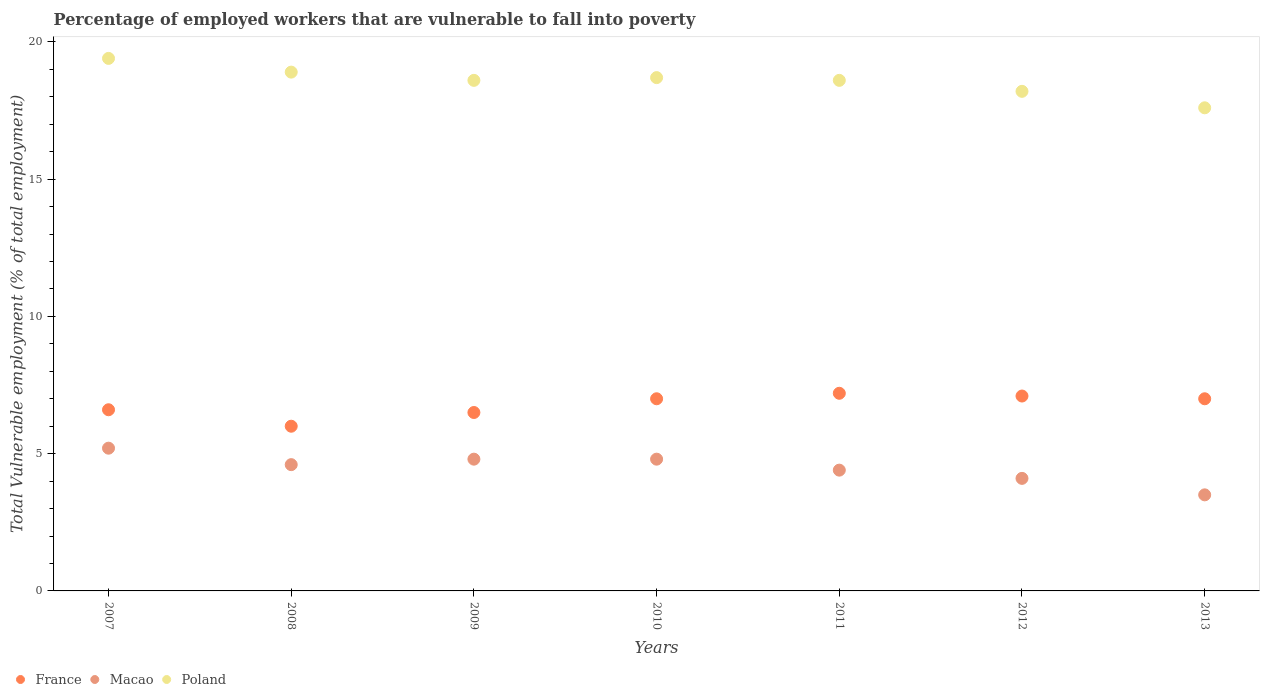Is the number of dotlines equal to the number of legend labels?
Make the answer very short. Yes. What is the percentage of employed workers who are vulnerable to fall into poverty in Macao in 2013?
Your answer should be very brief. 3.5. Across all years, what is the maximum percentage of employed workers who are vulnerable to fall into poverty in Poland?
Offer a very short reply. 19.4. In which year was the percentage of employed workers who are vulnerable to fall into poverty in Poland maximum?
Keep it short and to the point. 2007. In which year was the percentage of employed workers who are vulnerable to fall into poverty in Macao minimum?
Keep it short and to the point. 2013. What is the total percentage of employed workers who are vulnerable to fall into poverty in France in the graph?
Make the answer very short. 47.4. What is the difference between the percentage of employed workers who are vulnerable to fall into poverty in France in 2007 and that in 2012?
Keep it short and to the point. -0.5. What is the difference between the percentage of employed workers who are vulnerable to fall into poverty in France in 2012 and the percentage of employed workers who are vulnerable to fall into poverty in Macao in 2009?
Your answer should be compact. 2.3. What is the average percentage of employed workers who are vulnerable to fall into poverty in Macao per year?
Provide a succinct answer. 4.49. In the year 2007, what is the difference between the percentage of employed workers who are vulnerable to fall into poverty in Macao and percentage of employed workers who are vulnerable to fall into poverty in Poland?
Offer a very short reply. -14.2. In how many years, is the percentage of employed workers who are vulnerable to fall into poverty in Poland greater than 19 %?
Ensure brevity in your answer.  1. What is the ratio of the percentage of employed workers who are vulnerable to fall into poverty in Macao in 2007 to that in 2008?
Provide a succinct answer. 1.13. Is the percentage of employed workers who are vulnerable to fall into poverty in Macao in 2007 less than that in 2009?
Your response must be concise. No. What is the difference between the highest and the second highest percentage of employed workers who are vulnerable to fall into poverty in France?
Your answer should be compact. 0.1. What is the difference between the highest and the lowest percentage of employed workers who are vulnerable to fall into poverty in France?
Your answer should be very brief. 1.2. In how many years, is the percentage of employed workers who are vulnerable to fall into poverty in Macao greater than the average percentage of employed workers who are vulnerable to fall into poverty in Macao taken over all years?
Provide a succinct answer. 4. Is it the case that in every year, the sum of the percentage of employed workers who are vulnerable to fall into poverty in France and percentage of employed workers who are vulnerable to fall into poverty in Macao  is greater than the percentage of employed workers who are vulnerable to fall into poverty in Poland?
Offer a very short reply. No. Is the percentage of employed workers who are vulnerable to fall into poverty in France strictly greater than the percentage of employed workers who are vulnerable to fall into poverty in Poland over the years?
Ensure brevity in your answer.  No. How many years are there in the graph?
Ensure brevity in your answer.  7. Are the values on the major ticks of Y-axis written in scientific E-notation?
Make the answer very short. No. Does the graph contain any zero values?
Your answer should be compact. No. How many legend labels are there?
Your response must be concise. 3. How are the legend labels stacked?
Your response must be concise. Horizontal. What is the title of the graph?
Offer a very short reply. Percentage of employed workers that are vulnerable to fall into poverty. What is the label or title of the Y-axis?
Your answer should be compact. Total Vulnerable employment (% of total employment). What is the Total Vulnerable employment (% of total employment) of France in 2007?
Your answer should be very brief. 6.6. What is the Total Vulnerable employment (% of total employment) of Macao in 2007?
Offer a very short reply. 5.2. What is the Total Vulnerable employment (% of total employment) of Poland in 2007?
Keep it short and to the point. 19.4. What is the Total Vulnerable employment (% of total employment) of Macao in 2008?
Your answer should be very brief. 4.6. What is the Total Vulnerable employment (% of total employment) in Poland in 2008?
Make the answer very short. 18.9. What is the Total Vulnerable employment (% of total employment) of Macao in 2009?
Make the answer very short. 4.8. What is the Total Vulnerable employment (% of total employment) in Poland in 2009?
Ensure brevity in your answer.  18.6. What is the Total Vulnerable employment (% of total employment) of France in 2010?
Ensure brevity in your answer.  7. What is the Total Vulnerable employment (% of total employment) of Macao in 2010?
Your answer should be compact. 4.8. What is the Total Vulnerable employment (% of total employment) of Poland in 2010?
Ensure brevity in your answer.  18.7. What is the Total Vulnerable employment (% of total employment) in France in 2011?
Give a very brief answer. 7.2. What is the Total Vulnerable employment (% of total employment) in Macao in 2011?
Offer a terse response. 4.4. What is the Total Vulnerable employment (% of total employment) in Poland in 2011?
Your answer should be very brief. 18.6. What is the Total Vulnerable employment (% of total employment) in France in 2012?
Your answer should be very brief. 7.1. What is the Total Vulnerable employment (% of total employment) of Macao in 2012?
Give a very brief answer. 4.1. What is the Total Vulnerable employment (% of total employment) of Poland in 2012?
Offer a very short reply. 18.2. What is the Total Vulnerable employment (% of total employment) of Poland in 2013?
Ensure brevity in your answer.  17.6. Across all years, what is the maximum Total Vulnerable employment (% of total employment) in France?
Your response must be concise. 7.2. Across all years, what is the maximum Total Vulnerable employment (% of total employment) in Macao?
Provide a short and direct response. 5.2. Across all years, what is the maximum Total Vulnerable employment (% of total employment) in Poland?
Give a very brief answer. 19.4. Across all years, what is the minimum Total Vulnerable employment (% of total employment) of France?
Provide a short and direct response. 6. Across all years, what is the minimum Total Vulnerable employment (% of total employment) of Macao?
Your answer should be very brief. 3.5. Across all years, what is the minimum Total Vulnerable employment (% of total employment) in Poland?
Your answer should be compact. 17.6. What is the total Total Vulnerable employment (% of total employment) of France in the graph?
Your response must be concise. 47.4. What is the total Total Vulnerable employment (% of total employment) of Macao in the graph?
Offer a very short reply. 31.4. What is the total Total Vulnerable employment (% of total employment) of Poland in the graph?
Provide a short and direct response. 130. What is the difference between the Total Vulnerable employment (% of total employment) in France in 2007 and that in 2009?
Ensure brevity in your answer.  0.1. What is the difference between the Total Vulnerable employment (% of total employment) of Poland in 2007 and that in 2009?
Offer a terse response. 0.8. What is the difference between the Total Vulnerable employment (% of total employment) of France in 2007 and that in 2010?
Your response must be concise. -0.4. What is the difference between the Total Vulnerable employment (% of total employment) of Macao in 2007 and that in 2010?
Provide a short and direct response. 0.4. What is the difference between the Total Vulnerable employment (% of total employment) in Poland in 2007 and that in 2010?
Provide a short and direct response. 0.7. What is the difference between the Total Vulnerable employment (% of total employment) in France in 2007 and that in 2011?
Offer a very short reply. -0.6. What is the difference between the Total Vulnerable employment (% of total employment) of France in 2007 and that in 2012?
Your response must be concise. -0.5. What is the difference between the Total Vulnerable employment (% of total employment) of Macao in 2007 and that in 2012?
Make the answer very short. 1.1. What is the difference between the Total Vulnerable employment (% of total employment) in France in 2007 and that in 2013?
Offer a very short reply. -0.4. What is the difference between the Total Vulnerable employment (% of total employment) in Macao in 2007 and that in 2013?
Your response must be concise. 1.7. What is the difference between the Total Vulnerable employment (% of total employment) of Poland in 2007 and that in 2013?
Your response must be concise. 1.8. What is the difference between the Total Vulnerable employment (% of total employment) of Poland in 2008 and that in 2009?
Your answer should be very brief. 0.3. What is the difference between the Total Vulnerable employment (% of total employment) of France in 2008 and that in 2010?
Offer a very short reply. -1. What is the difference between the Total Vulnerable employment (% of total employment) of Macao in 2008 and that in 2010?
Provide a short and direct response. -0.2. What is the difference between the Total Vulnerable employment (% of total employment) in Poland in 2008 and that in 2010?
Keep it short and to the point. 0.2. What is the difference between the Total Vulnerable employment (% of total employment) in Macao in 2008 and that in 2011?
Give a very brief answer. 0.2. What is the difference between the Total Vulnerable employment (% of total employment) in Macao in 2008 and that in 2012?
Provide a succinct answer. 0.5. What is the difference between the Total Vulnerable employment (% of total employment) of France in 2008 and that in 2013?
Your answer should be compact. -1. What is the difference between the Total Vulnerable employment (% of total employment) in Macao in 2008 and that in 2013?
Offer a very short reply. 1.1. What is the difference between the Total Vulnerable employment (% of total employment) of Poland in 2008 and that in 2013?
Your answer should be compact. 1.3. What is the difference between the Total Vulnerable employment (% of total employment) of Poland in 2009 and that in 2010?
Offer a terse response. -0.1. What is the difference between the Total Vulnerable employment (% of total employment) in France in 2009 and that in 2011?
Offer a very short reply. -0.7. What is the difference between the Total Vulnerable employment (% of total employment) of France in 2009 and that in 2012?
Your response must be concise. -0.6. What is the difference between the Total Vulnerable employment (% of total employment) of France in 2009 and that in 2013?
Offer a terse response. -0.5. What is the difference between the Total Vulnerable employment (% of total employment) of Macao in 2009 and that in 2013?
Keep it short and to the point. 1.3. What is the difference between the Total Vulnerable employment (% of total employment) of Poland in 2009 and that in 2013?
Offer a terse response. 1. What is the difference between the Total Vulnerable employment (% of total employment) of France in 2010 and that in 2011?
Your answer should be very brief. -0.2. What is the difference between the Total Vulnerable employment (% of total employment) in Poland in 2010 and that in 2011?
Offer a terse response. 0.1. What is the difference between the Total Vulnerable employment (% of total employment) in France in 2010 and that in 2012?
Provide a succinct answer. -0.1. What is the difference between the Total Vulnerable employment (% of total employment) in France in 2010 and that in 2013?
Keep it short and to the point. 0. What is the difference between the Total Vulnerable employment (% of total employment) of Macao in 2010 and that in 2013?
Your answer should be very brief. 1.3. What is the difference between the Total Vulnerable employment (% of total employment) of Poland in 2010 and that in 2013?
Ensure brevity in your answer.  1.1. What is the difference between the Total Vulnerable employment (% of total employment) of France in 2011 and that in 2012?
Make the answer very short. 0.1. What is the difference between the Total Vulnerable employment (% of total employment) in Macao in 2011 and that in 2012?
Make the answer very short. 0.3. What is the difference between the Total Vulnerable employment (% of total employment) in Poland in 2011 and that in 2012?
Your answer should be compact. 0.4. What is the difference between the Total Vulnerable employment (% of total employment) of France in 2011 and that in 2013?
Your answer should be very brief. 0.2. What is the difference between the Total Vulnerable employment (% of total employment) in Macao in 2011 and that in 2013?
Give a very brief answer. 0.9. What is the difference between the Total Vulnerable employment (% of total employment) of Poland in 2011 and that in 2013?
Ensure brevity in your answer.  1. What is the difference between the Total Vulnerable employment (% of total employment) in Macao in 2012 and that in 2013?
Give a very brief answer. 0.6. What is the difference between the Total Vulnerable employment (% of total employment) of Poland in 2012 and that in 2013?
Keep it short and to the point. 0.6. What is the difference between the Total Vulnerable employment (% of total employment) of Macao in 2007 and the Total Vulnerable employment (% of total employment) of Poland in 2008?
Ensure brevity in your answer.  -13.7. What is the difference between the Total Vulnerable employment (% of total employment) of France in 2007 and the Total Vulnerable employment (% of total employment) of Macao in 2009?
Offer a very short reply. 1.8. What is the difference between the Total Vulnerable employment (% of total employment) in France in 2007 and the Total Vulnerable employment (% of total employment) in Macao in 2010?
Offer a very short reply. 1.8. What is the difference between the Total Vulnerable employment (% of total employment) of Macao in 2007 and the Total Vulnerable employment (% of total employment) of Poland in 2010?
Give a very brief answer. -13.5. What is the difference between the Total Vulnerable employment (% of total employment) of France in 2007 and the Total Vulnerable employment (% of total employment) of Macao in 2011?
Your response must be concise. 2.2. What is the difference between the Total Vulnerable employment (% of total employment) in Macao in 2007 and the Total Vulnerable employment (% of total employment) in Poland in 2011?
Provide a short and direct response. -13.4. What is the difference between the Total Vulnerable employment (% of total employment) of France in 2007 and the Total Vulnerable employment (% of total employment) of Macao in 2012?
Offer a very short reply. 2.5. What is the difference between the Total Vulnerable employment (% of total employment) of France in 2007 and the Total Vulnerable employment (% of total employment) of Macao in 2013?
Your answer should be very brief. 3.1. What is the difference between the Total Vulnerable employment (% of total employment) of France in 2007 and the Total Vulnerable employment (% of total employment) of Poland in 2013?
Keep it short and to the point. -11. What is the difference between the Total Vulnerable employment (% of total employment) in Macao in 2007 and the Total Vulnerable employment (% of total employment) in Poland in 2013?
Offer a terse response. -12.4. What is the difference between the Total Vulnerable employment (% of total employment) in France in 2008 and the Total Vulnerable employment (% of total employment) in Macao in 2009?
Keep it short and to the point. 1.2. What is the difference between the Total Vulnerable employment (% of total employment) of Macao in 2008 and the Total Vulnerable employment (% of total employment) of Poland in 2009?
Your response must be concise. -14. What is the difference between the Total Vulnerable employment (% of total employment) of France in 2008 and the Total Vulnerable employment (% of total employment) of Poland in 2010?
Make the answer very short. -12.7. What is the difference between the Total Vulnerable employment (% of total employment) in Macao in 2008 and the Total Vulnerable employment (% of total employment) in Poland in 2010?
Your response must be concise. -14.1. What is the difference between the Total Vulnerable employment (% of total employment) of France in 2008 and the Total Vulnerable employment (% of total employment) of Macao in 2012?
Make the answer very short. 1.9. What is the difference between the Total Vulnerable employment (% of total employment) of Macao in 2008 and the Total Vulnerable employment (% of total employment) of Poland in 2012?
Ensure brevity in your answer.  -13.6. What is the difference between the Total Vulnerable employment (% of total employment) in Macao in 2009 and the Total Vulnerable employment (% of total employment) in Poland in 2010?
Provide a short and direct response. -13.9. What is the difference between the Total Vulnerable employment (% of total employment) in France in 2009 and the Total Vulnerable employment (% of total employment) in Macao in 2011?
Your answer should be very brief. 2.1. What is the difference between the Total Vulnerable employment (% of total employment) in France in 2009 and the Total Vulnerable employment (% of total employment) in Poland in 2012?
Your response must be concise. -11.7. What is the difference between the Total Vulnerable employment (% of total employment) of Macao in 2009 and the Total Vulnerable employment (% of total employment) of Poland in 2012?
Your response must be concise. -13.4. What is the difference between the Total Vulnerable employment (% of total employment) in France in 2009 and the Total Vulnerable employment (% of total employment) in Poland in 2013?
Keep it short and to the point. -11.1. What is the difference between the Total Vulnerable employment (% of total employment) in Macao in 2009 and the Total Vulnerable employment (% of total employment) in Poland in 2013?
Your answer should be compact. -12.8. What is the difference between the Total Vulnerable employment (% of total employment) in France in 2010 and the Total Vulnerable employment (% of total employment) in Poland in 2011?
Keep it short and to the point. -11.6. What is the difference between the Total Vulnerable employment (% of total employment) of France in 2010 and the Total Vulnerable employment (% of total employment) of Poland in 2012?
Keep it short and to the point. -11.2. What is the difference between the Total Vulnerable employment (% of total employment) in Macao in 2010 and the Total Vulnerable employment (% of total employment) in Poland in 2012?
Offer a very short reply. -13.4. What is the difference between the Total Vulnerable employment (% of total employment) in Macao in 2010 and the Total Vulnerable employment (% of total employment) in Poland in 2013?
Give a very brief answer. -12.8. What is the difference between the Total Vulnerable employment (% of total employment) of France in 2011 and the Total Vulnerable employment (% of total employment) of Macao in 2012?
Ensure brevity in your answer.  3.1. What is the difference between the Total Vulnerable employment (% of total employment) in France in 2011 and the Total Vulnerable employment (% of total employment) in Poland in 2012?
Provide a succinct answer. -11. What is the difference between the Total Vulnerable employment (% of total employment) in Macao in 2011 and the Total Vulnerable employment (% of total employment) in Poland in 2012?
Your answer should be compact. -13.8. What is the difference between the Total Vulnerable employment (% of total employment) of France in 2011 and the Total Vulnerable employment (% of total employment) of Macao in 2013?
Keep it short and to the point. 3.7. What is the difference between the Total Vulnerable employment (% of total employment) in France in 2011 and the Total Vulnerable employment (% of total employment) in Poland in 2013?
Your answer should be very brief. -10.4. What is the difference between the Total Vulnerable employment (% of total employment) of Macao in 2011 and the Total Vulnerable employment (% of total employment) of Poland in 2013?
Provide a short and direct response. -13.2. What is the difference between the Total Vulnerable employment (% of total employment) in France in 2012 and the Total Vulnerable employment (% of total employment) in Poland in 2013?
Ensure brevity in your answer.  -10.5. What is the difference between the Total Vulnerable employment (% of total employment) of Macao in 2012 and the Total Vulnerable employment (% of total employment) of Poland in 2013?
Provide a short and direct response. -13.5. What is the average Total Vulnerable employment (% of total employment) of France per year?
Provide a short and direct response. 6.77. What is the average Total Vulnerable employment (% of total employment) in Macao per year?
Make the answer very short. 4.49. What is the average Total Vulnerable employment (% of total employment) of Poland per year?
Keep it short and to the point. 18.57. In the year 2007, what is the difference between the Total Vulnerable employment (% of total employment) in France and Total Vulnerable employment (% of total employment) in Macao?
Offer a terse response. 1.4. In the year 2007, what is the difference between the Total Vulnerable employment (% of total employment) of France and Total Vulnerable employment (% of total employment) of Poland?
Your response must be concise. -12.8. In the year 2008, what is the difference between the Total Vulnerable employment (% of total employment) in France and Total Vulnerable employment (% of total employment) in Macao?
Keep it short and to the point. 1.4. In the year 2008, what is the difference between the Total Vulnerable employment (% of total employment) in Macao and Total Vulnerable employment (% of total employment) in Poland?
Keep it short and to the point. -14.3. In the year 2009, what is the difference between the Total Vulnerable employment (% of total employment) of France and Total Vulnerable employment (% of total employment) of Poland?
Provide a short and direct response. -12.1. In the year 2009, what is the difference between the Total Vulnerable employment (% of total employment) of Macao and Total Vulnerable employment (% of total employment) of Poland?
Provide a succinct answer. -13.8. In the year 2010, what is the difference between the Total Vulnerable employment (% of total employment) in France and Total Vulnerable employment (% of total employment) in Poland?
Offer a very short reply. -11.7. In the year 2010, what is the difference between the Total Vulnerable employment (% of total employment) in Macao and Total Vulnerable employment (% of total employment) in Poland?
Ensure brevity in your answer.  -13.9. In the year 2011, what is the difference between the Total Vulnerable employment (% of total employment) in France and Total Vulnerable employment (% of total employment) in Macao?
Make the answer very short. 2.8. In the year 2011, what is the difference between the Total Vulnerable employment (% of total employment) in Macao and Total Vulnerable employment (% of total employment) in Poland?
Your answer should be compact. -14.2. In the year 2012, what is the difference between the Total Vulnerable employment (% of total employment) in France and Total Vulnerable employment (% of total employment) in Macao?
Keep it short and to the point. 3. In the year 2012, what is the difference between the Total Vulnerable employment (% of total employment) of Macao and Total Vulnerable employment (% of total employment) of Poland?
Keep it short and to the point. -14.1. In the year 2013, what is the difference between the Total Vulnerable employment (% of total employment) in France and Total Vulnerable employment (% of total employment) in Poland?
Give a very brief answer. -10.6. In the year 2013, what is the difference between the Total Vulnerable employment (% of total employment) in Macao and Total Vulnerable employment (% of total employment) in Poland?
Provide a succinct answer. -14.1. What is the ratio of the Total Vulnerable employment (% of total employment) in Macao in 2007 to that in 2008?
Your response must be concise. 1.13. What is the ratio of the Total Vulnerable employment (% of total employment) of Poland in 2007 to that in 2008?
Your answer should be compact. 1.03. What is the ratio of the Total Vulnerable employment (% of total employment) in France in 2007 to that in 2009?
Your response must be concise. 1.02. What is the ratio of the Total Vulnerable employment (% of total employment) of Macao in 2007 to that in 2009?
Your answer should be very brief. 1.08. What is the ratio of the Total Vulnerable employment (% of total employment) of Poland in 2007 to that in 2009?
Ensure brevity in your answer.  1.04. What is the ratio of the Total Vulnerable employment (% of total employment) in France in 2007 to that in 2010?
Your answer should be very brief. 0.94. What is the ratio of the Total Vulnerable employment (% of total employment) of Macao in 2007 to that in 2010?
Make the answer very short. 1.08. What is the ratio of the Total Vulnerable employment (% of total employment) in Poland in 2007 to that in 2010?
Your response must be concise. 1.04. What is the ratio of the Total Vulnerable employment (% of total employment) of Macao in 2007 to that in 2011?
Make the answer very short. 1.18. What is the ratio of the Total Vulnerable employment (% of total employment) of Poland in 2007 to that in 2011?
Offer a very short reply. 1.04. What is the ratio of the Total Vulnerable employment (% of total employment) of France in 2007 to that in 2012?
Ensure brevity in your answer.  0.93. What is the ratio of the Total Vulnerable employment (% of total employment) in Macao in 2007 to that in 2012?
Provide a succinct answer. 1.27. What is the ratio of the Total Vulnerable employment (% of total employment) of Poland in 2007 to that in 2012?
Provide a succinct answer. 1.07. What is the ratio of the Total Vulnerable employment (% of total employment) of France in 2007 to that in 2013?
Provide a succinct answer. 0.94. What is the ratio of the Total Vulnerable employment (% of total employment) of Macao in 2007 to that in 2013?
Offer a terse response. 1.49. What is the ratio of the Total Vulnerable employment (% of total employment) of Poland in 2007 to that in 2013?
Give a very brief answer. 1.1. What is the ratio of the Total Vulnerable employment (% of total employment) in Macao in 2008 to that in 2009?
Your response must be concise. 0.96. What is the ratio of the Total Vulnerable employment (% of total employment) of Poland in 2008 to that in 2009?
Ensure brevity in your answer.  1.02. What is the ratio of the Total Vulnerable employment (% of total employment) in France in 2008 to that in 2010?
Make the answer very short. 0.86. What is the ratio of the Total Vulnerable employment (% of total employment) in Macao in 2008 to that in 2010?
Offer a terse response. 0.96. What is the ratio of the Total Vulnerable employment (% of total employment) of Poland in 2008 to that in 2010?
Provide a short and direct response. 1.01. What is the ratio of the Total Vulnerable employment (% of total employment) of Macao in 2008 to that in 2011?
Make the answer very short. 1.05. What is the ratio of the Total Vulnerable employment (% of total employment) of Poland in 2008 to that in 2011?
Your answer should be compact. 1.02. What is the ratio of the Total Vulnerable employment (% of total employment) of France in 2008 to that in 2012?
Ensure brevity in your answer.  0.85. What is the ratio of the Total Vulnerable employment (% of total employment) of Macao in 2008 to that in 2012?
Give a very brief answer. 1.12. What is the ratio of the Total Vulnerable employment (% of total employment) of France in 2008 to that in 2013?
Ensure brevity in your answer.  0.86. What is the ratio of the Total Vulnerable employment (% of total employment) of Macao in 2008 to that in 2013?
Your answer should be compact. 1.31. What is the ratio of the Total Vulnerable employment (% of total employment) of Poland in 2008 to that in 2013?
Offer a very short reply. 1.07. What is the ratio of the Total Vulnerable employment (% of total employment) in Poland in 2009 to that in 2010?
Provide a short and direct response. 0.99. What is the ratio of the Total Vulnerable employment (% of total employment) in France in 2009 to that in 2011?
Provide a succinct answer. 0.9. What is the ratio of the Total Vulnerable employment (% of total employment) of Macao in 2009 to that in 2011?
Your answer should be very brief. 1.09. What is the ratio of the Total Vulnerable employment (% of total employment) of France in 2009 to that in 2012?
Ensure brevity in your answer.  0.92. What is the ratio of the Total Vulnerable employment (% of total employment) of Macao in 2009 to that in 2012?
Offer a terse response. 1.17. What is the ratio of the Total Vulnerable employment (% of total employment) in Macao in 2009 to that in 2013?
Ensure brevity in your answer.  1.37. What is the ratio of the Total Vulnerable employment (% of total employment) in Poland in 2009 to that in 2013?
Your answer should be very brief. 1.06. What is the ratio of the Total Vulnerable employment (% of total employment) in France in 2010 to that in 2011?
Provide a succinct answer. 0.97. What is the ratio of the Total Vulnerable employment (% of total employment) in Poland in 2010 to that in 2011?
Ensure brevity in your answer.  1.01. What is the ratio of the Total Vulnerable employment (% of total employment) in France in 2010 to that in 2012?
Give a very brief answer. 0.99. What is the ratio of the Total Vulnerable employment (% of total employment) in Macao in 2010 to that in 2012?
Ensure brevity in your answer.  1.17. What is the ratio of the Total Vulnerable employment (% of total employment) in Poland in 2010 to that in 2012?
Provide a short and direct response. 1.03. What is the ratio of the Total Vulnerable employment (% of total employment) of France in 2010 to that in 2013?
Provide a succinct answer. 1. What is the ratio of the Total Vulnerable employment (% of total employment) of Macao in 2010 to that in 2013?
Provide a succinct answer. 1.37. What is the ratio of the Total Vulnerable employment (% of total employment) of Poland in 2010 to that in 2013?
Give a very brief answer. 1.06. What is the ratio of the Total Vulnerable employment (% of total employment) in France in 2011 to that in 2012?
Your response must be concise. 1.01. What is the ratio of the Total Vulnerable employment (% of total employment) in Macao in 2011 to that in 2012?
Make the answer very short. 1.07. What is the ratio of the Total Vulnerable employment (% of total employment) of France in 2011 to that in 2013?
Provide a short and direct response. 1.03. What is the ratio of the Total Vulnerable employment (% of total employment) in Macao in 2011 to that in 2013?
Make the answer very short. 1.26. What is the ratio of the Total Vulnerable employment (% of total employment) of Poland in 2011 to that in 2013?
Ensure brevity in your answer.  1.06. What is the ratio of the Total Vulnerable employment (% of total employment) in France in 2012 to that in 2013?
Keep it short and to the point. 1.01. What is the ratio of the Total Vulnerable employment (% of total employment) of Macao in 2012 to that in 2013?
Give a very brief answer. 1.17. What is the ratio of the Total Vulnerable employment (% of total employment) of Poland in 2012 to that in 2013?
Provide a succinct answer. 1.03. What is the difference between the highest and the second highest Total Vulnerable employment (% of total employment) of France?
Offer a terse response. 0.1. What is the difference between the highest and the lowest Total Vulnerable employment (% of total employment) in France?
Your answer should be compact. 1.2. 